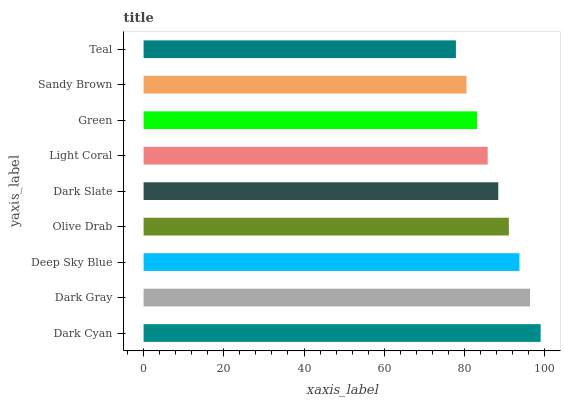Is Teal the minimum?
Answer yes or no. Yes. Is Dark Cyan the maximum?
Answer yes or no. Yes. Is Dark Gray the minimum?
Answer yes or no. No. Is Dark Gray the maximum?
Answer yes or no. No. Is Dark Cyan greater than Dark Gray?
Answer yes or no. Yes. Is Dark Gray less than Dark Cyan?
Answer yes or no. Yes. Is Dark Gray greater than Dark Cyan?
Answer yes or no. No. Is Dark Cyan less than Dark Gray?
Answer yes or no. No. Is Dark Slate the high median?
Answer yes or no. Yes. Is Dark Slate the low median?
Answer yes or no. Yes. Is Sandy Brown the high median?
Answer yes or no. No. Is Deep Sky Blue the low median?
Answer yes or no. No. 